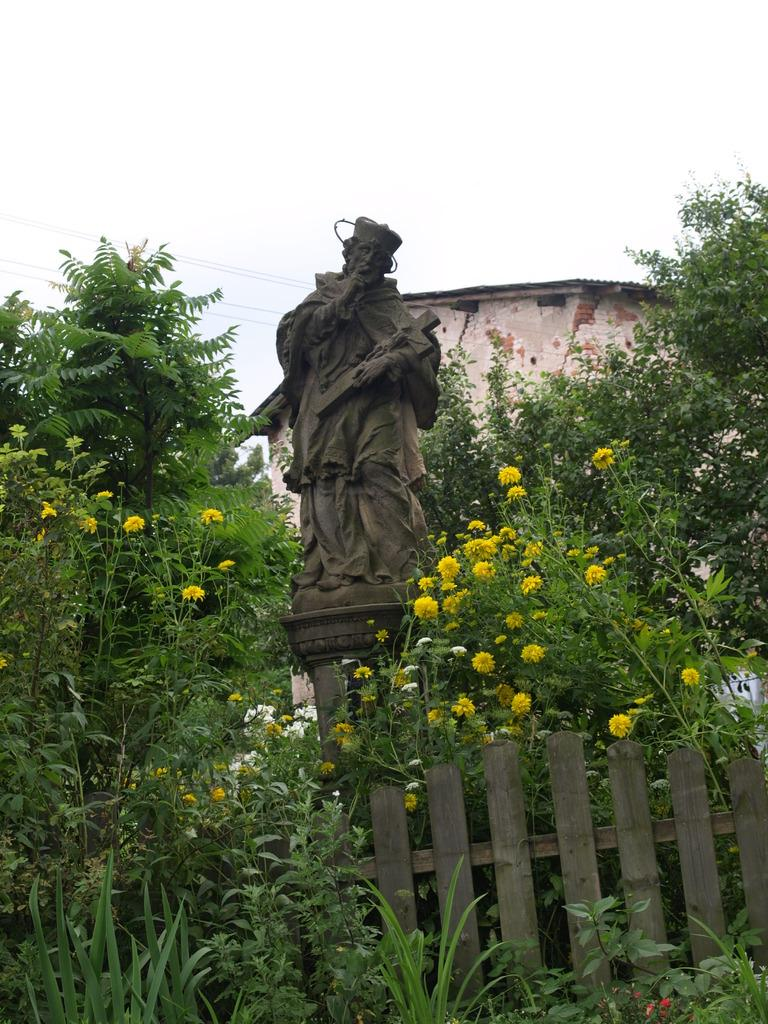What type of vegetation can be seen in the image? There are trees and plants with flowers in the image. What can be seen in the background of the image? There is a building in the background of the image. What is the statue in the image depicting? The specific details of the statue cannot be determined from the image. What type of barrier is present in the image? There is a wooden fence in the image. What is the condition of the sky in the image? The sky is cloudy in the image. What type of polish is the statue using in the image? There is no indication in the image that the statue is using any polish. How many lizards can be seen climbing the trees in the image? There are no lizards present in the image. 